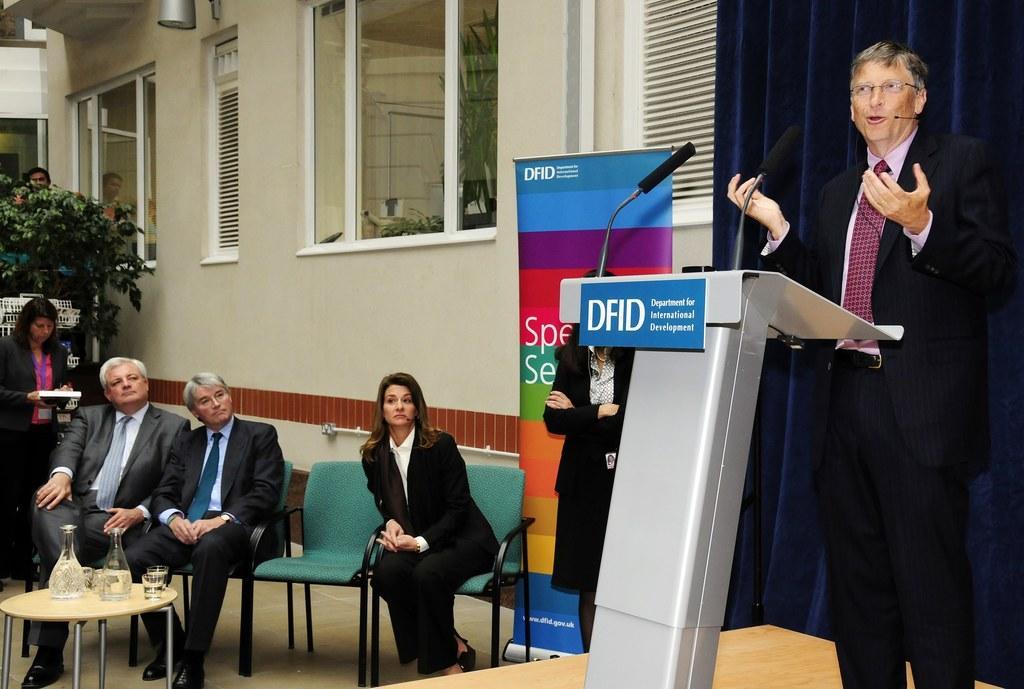In one or two sentences, can you explain what this image depicts? In this picture we can see man with mic and standing in front of podium and talking and beside to them there are some people listening to him and in front of them there is table and on table we can see jar, glasses and background we can see windows, banner, tree. 